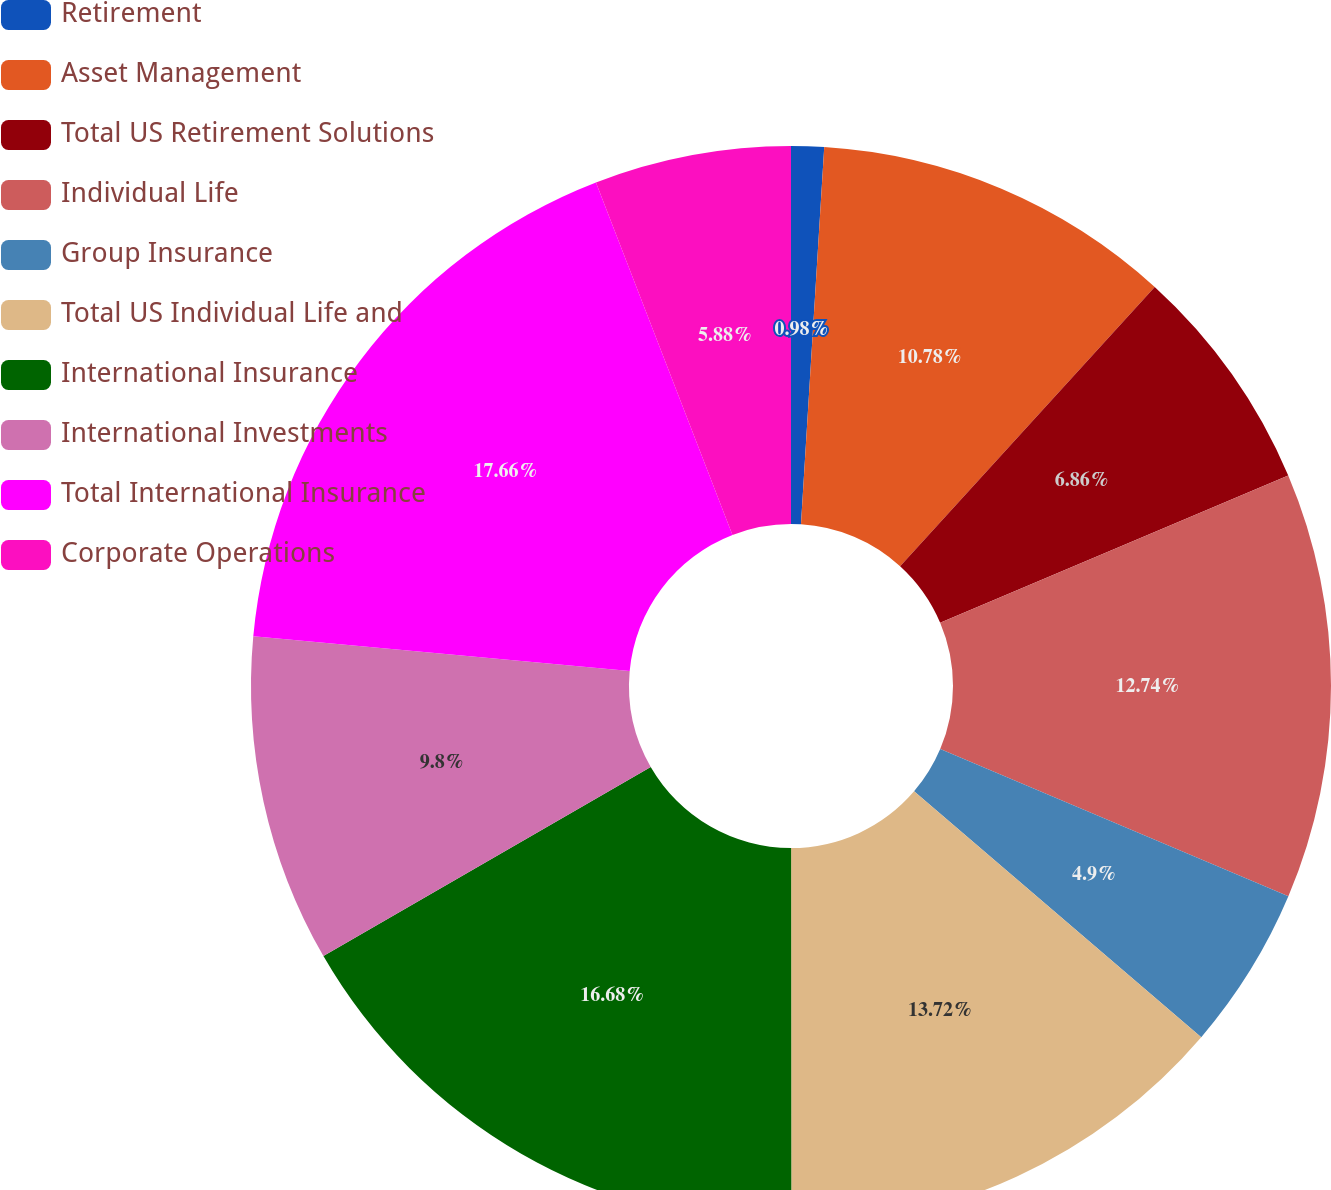<chart> <loc_0><loc_0><loc_500><loc_500><pie_chart><fcel>Retirement<fcel>Asset Management<fcel>Total US Retirement Solutions<fcel>Individual Life<fcel>Group Insurance<fcel>Total US Individual Life and<fcel>International Insurance<fcel>International Investments<fcel>Total International Insurance<fcel>Corporate Operations<nl><fcel>0.98%<fcel>10.78%<fcel>6.86%<fcel>12.74%<fcel>4.9%<fcel>13.72%<fcel>16.67%<fcel>9.8%<fcel>17.65%<fcel>5.88%<nl></chart> 